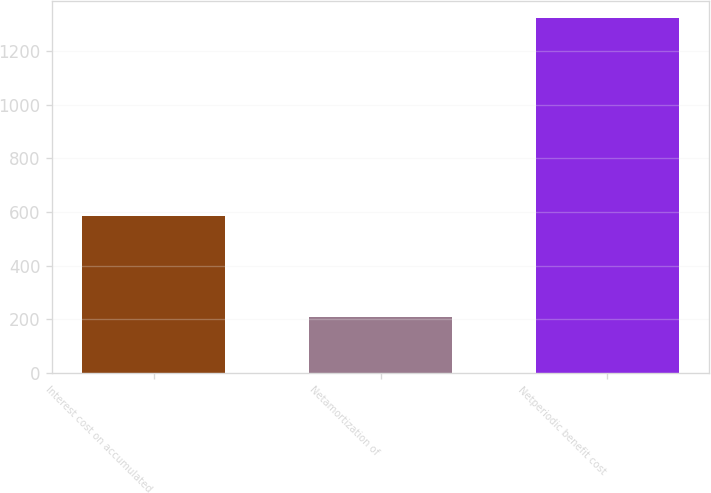Convert chart. <chart><loc_0><loc_0><loc_500><loc_500><bar_chart><fcel>Interest cost on accumulated<fcel>Netamortization of<fcel>Netperiodic benefit cost<nl><fcel>586<fcel>208<fcel>1323<nl></chart> 